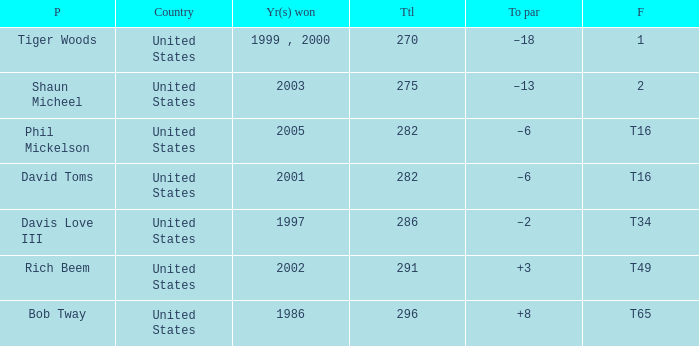Could you help me parse every detail presented in this table? {'header': ['P', 'Country', 'Yr(s) won', 'Ttl', 'To par', 'F'], 'rows': [['Tiger Woods', 'United States', '1999 , 2000', '270', '–18', '1'], ['Shaun Micheel', 'United States', '2003', '275', '–13', '2'], ['Phil Mickelson', 'United States', '2005', '282', '–6', 'T16'], ['David Toms', 'United States', '2001', '282', '–6', 'T16'], ['Davis Love III', 'United States', '1997', '286', '–2', 'T34'], ['Rich Beem', 'United States', '2002', '291', '+3', 'T49'], ['Bob Tway', 'United States', '1986', '296', '+8', 'T65']]} In which year(s) did the person who has a total of 291 win? 2002.0. 